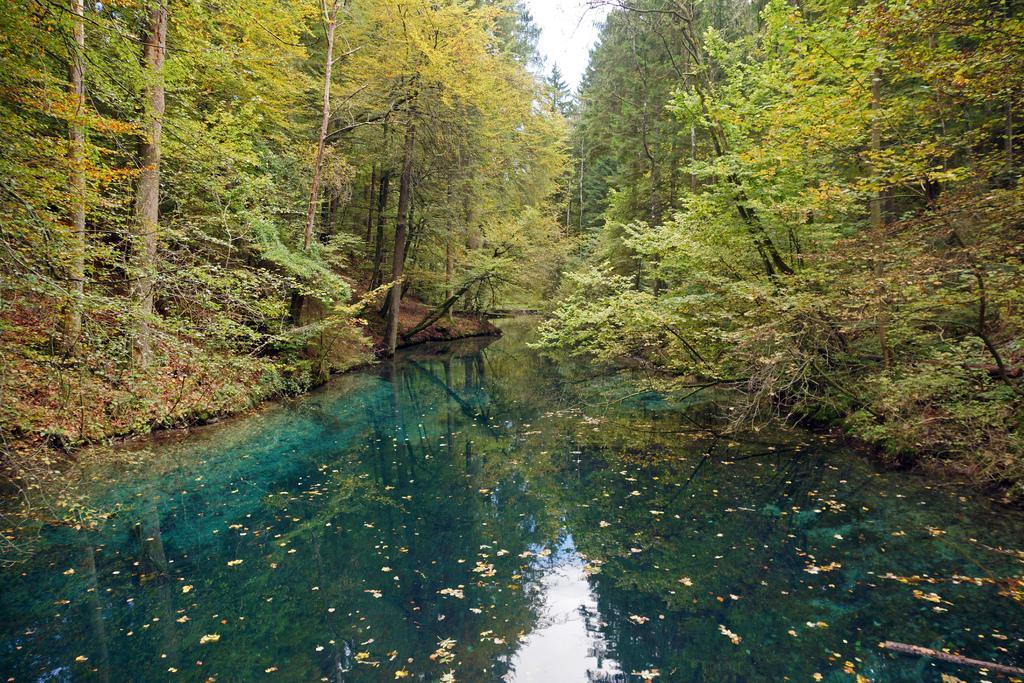In one or two sentences, can you explain what this image depicts? In this image we can see the water. Behind the water we can see a group of trees. At the top we can see the sky. On the water we can see the dried leaves and reflection of trees and the sky. 